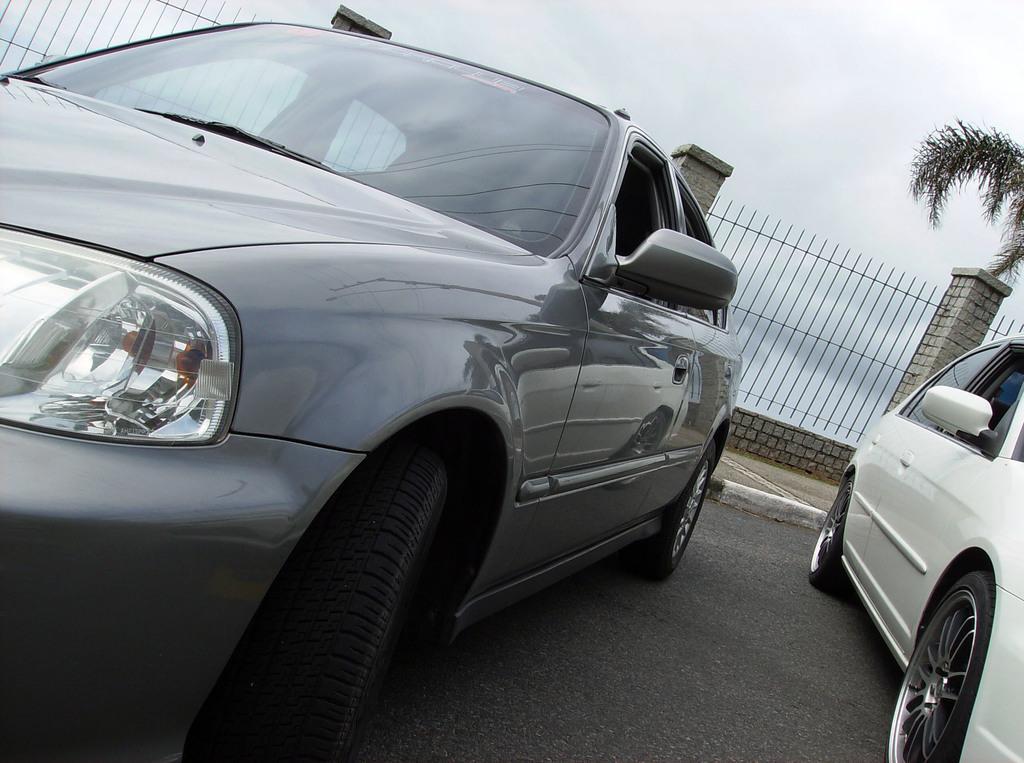Describe this image in one or two sentences. In this picture I can see the grey and white color cars near to the fencing. At the bottom I can see the road. On the right there is a tree. At the top I can see the sky and clouds. 